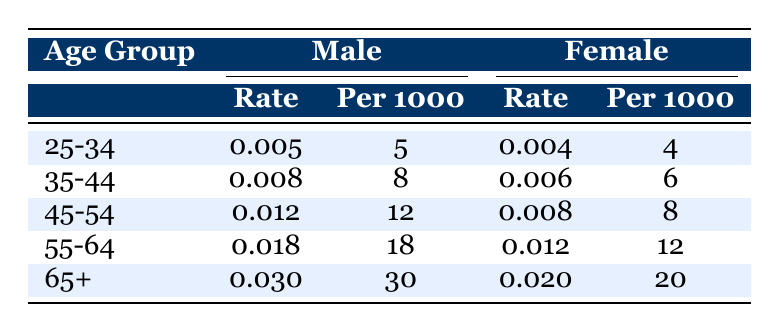What is the mortality rate for males aged 25-34? The table shows the row for the age group 25-34 under the Male column, where the mortality rate is listed as 0.005.
Answer: 0.005 What is the mortality rate for females aged 45-54? By looking at the 45-54 age group in the Female column, the mortality rate is indicated as 0.008.
Answer: 0.008 Is the mortality rate for females higher than that for males in the 35-44 age group? In the 35-44 age group, the mortality rate for males is 0.008, while for females it is 0.006. Since 0.008 is greater than 0.006, the statement is false.
Answer: No What is the combined mortality rate for males and females aged 55-64? The mortality rate for males in this age group is 0.018 and for females is 0.012. To find the combined rate, add them: 0.018 + 0.012 = 0.030.
Answer: 0.030 Which gender has a higher mortality rate in the 65+ age group? The table shows that for the 65+ age group, the mortality rate for males is 0.030 and for females is 0.020. Since 0.030 is greater than 0.020, males have a higher rate.
Answer: Males What is the difference in mortality rates between females aged 25-34 and females aged 55-64? The mortality rate for females in the 25-34 age group is 0.004, and for the 55-64 age group, it is 0.012. The difference is calculated by subtracting: 0.012 - 0.004 = 0.008.
Answer: 0.008 Are the mortality rates for males in the 45-54 age group higher than for males in the 55-64 age group? The mortality rate for males aged 45-54 is 0.012, while for those aged 55-64, it is 0.018. Since 0.018 is greater than 0.012, the statement is false.
Answer: No What is the average mortality rate across all age groups for females? First, find the mortality rates for females: 0.004, 0.006, 0.008, 0.012, and 0.020. Sum them: 0.004 + 0.006 + 0.008 + 0.012 + 0.020 = 0.050. There are 5 age groups, so the average is 0.050 / 5 = 0.010.
Answer: 0.010 